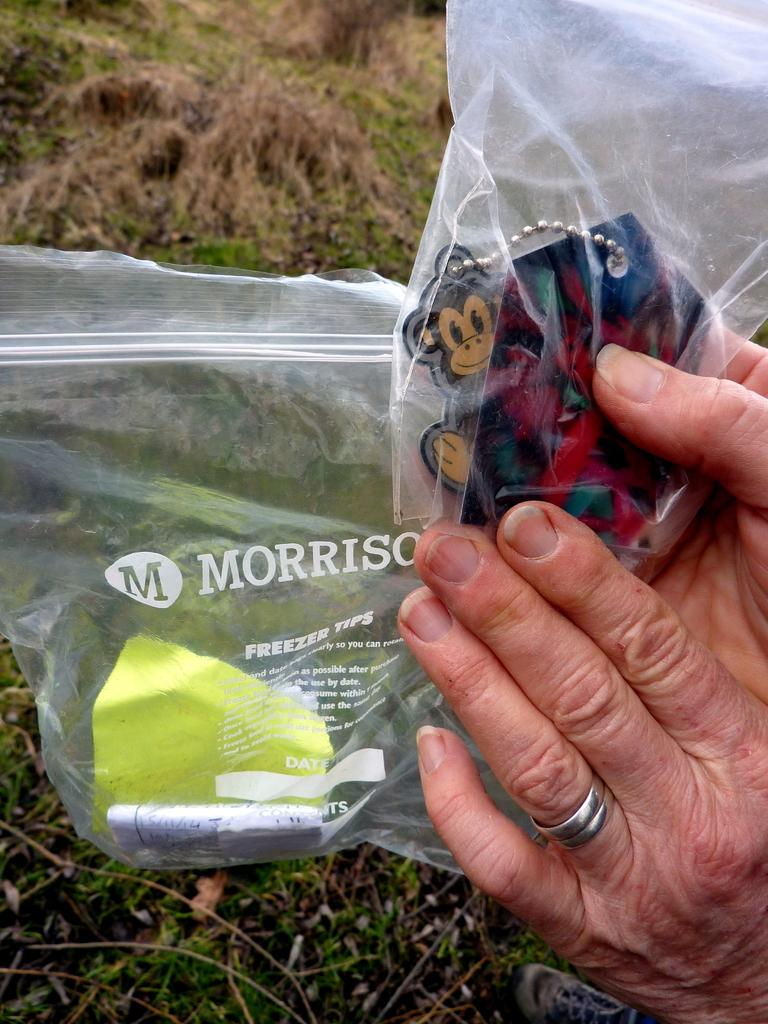What is the human hand holding in the image? The human hand is holding a cover in the image. What type of vegetation can be seen in the background of the image? There are dried grass and green-colored grass in the background of the image. Which direction is the fork pointing in the image? There is no fork present in the image. 